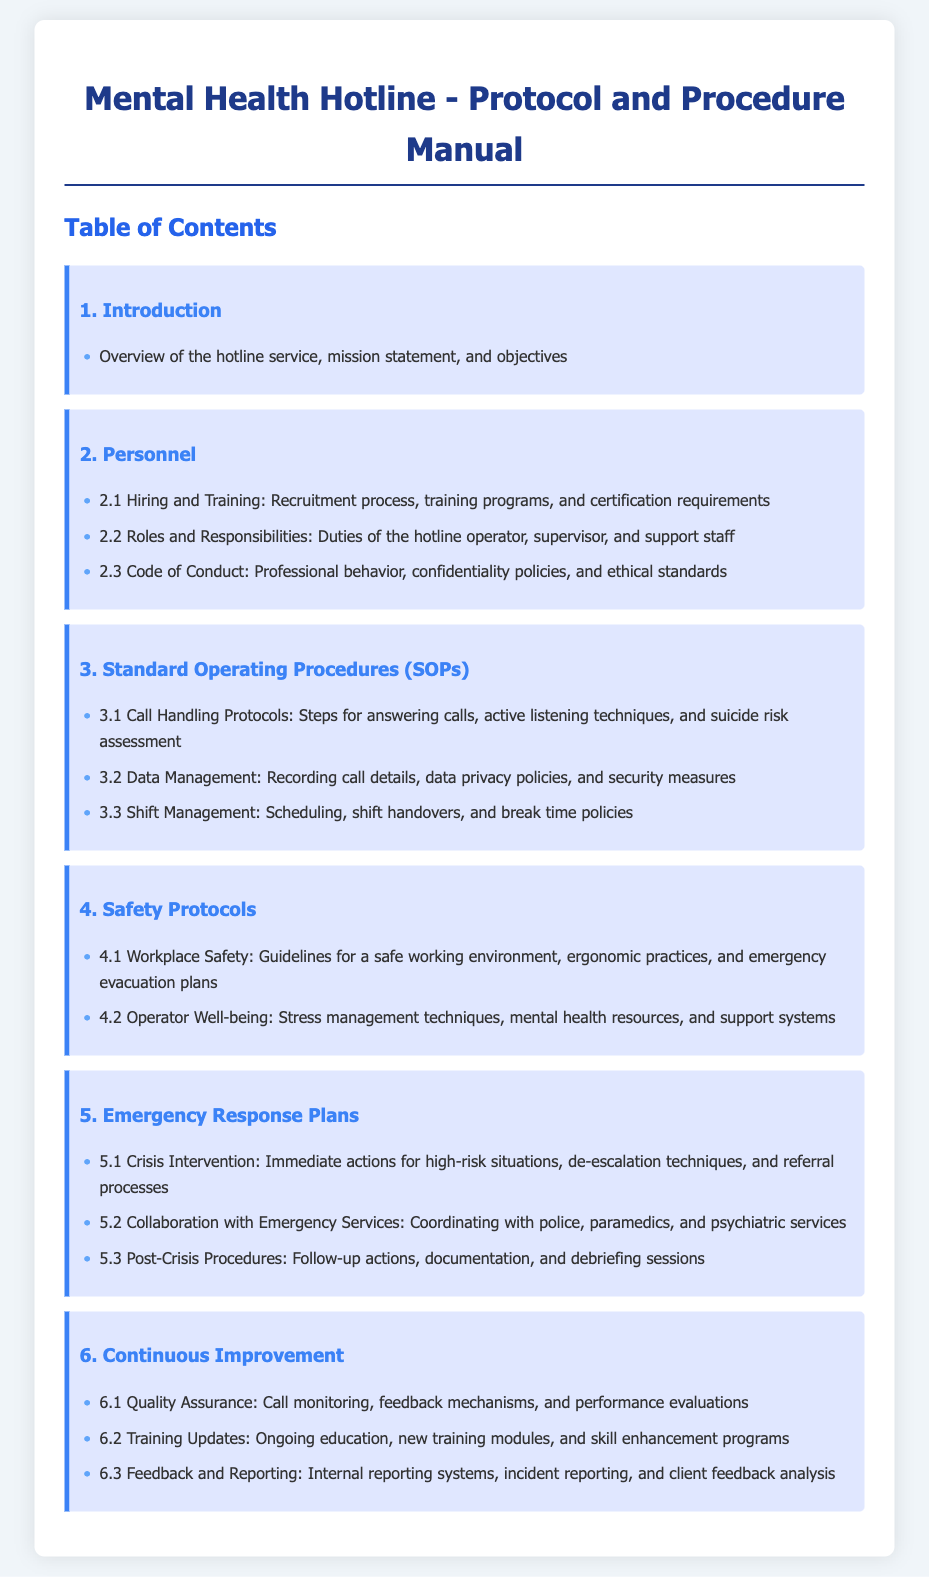what is the title of the document? The title of the document is indicated at the top of the page.
Answer: Mental Health Hotline - Protocol and Procedure Manual how many sections are in the table of contents? The sections are numbered from 1 to 6, which indicates the total number of sections.
Answer: 6 what is the main objective of the hotline service mentioned? The main objective is outlined in the introduction section.
Answer: Overview of the hotline service, mission statement, and objectives what is included in the Hiring and Training section? This section outlines the recruitment process, training programs, and certification requirements.
Answer: Recruitment process, training programs, and certification requirements what type of techniques are emphasized in Call Handling Protocols? The Call Handling Protocols section emphasizes specific techniques to assist operators during calls.
Answer: Active listening techniques how many parts are there under Emergency Response Plans? The Emergency Response Plans section contains multiple detailed parts focused on crisis situations.
Answer: 3 what is highlighted under Operator Well-being? This subsection focuses on specific techniques to support operators.
Answer: Stress management techniques what is the purpose of the Quality Assurance section? This section describes how performance is monitored and evaluated continuously.
Answer: Call monitoring, feedback mechanisms, and performance evaluations 